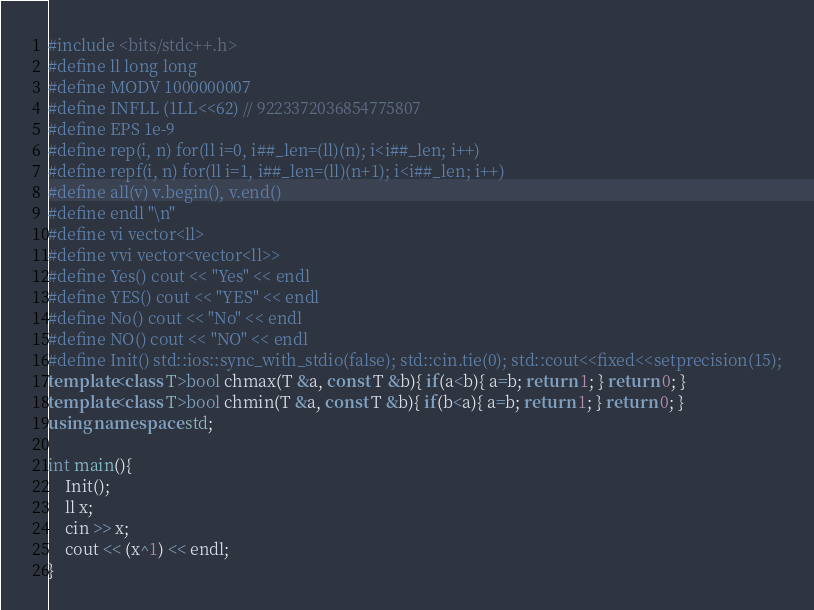Convert code to text. <code><loc_0><loc_0><loc_500><loc_500><_C++_>#include <bits/stdc++.h>
#define ll long long
#define MODV 1000000007
#define INFLL (1LL<<62) // 9223372036854775807
#define EPS 1e-9
#define rep(i, n) for(ll i=0, i##_len=(ll)(n); i<i##_len; i++)
#define repf(i, n) for(ll i=1, i##_len=(ll)(n+1); i<i##_len; i++)
#define all(v) v.begin(), v.end()
#define endl "\n"
#define vi vector<ll>
#define vvi vector<vector<ll>>
#define Yes() cout << "Yes" << endl
#define YES() cout << "YES" << endl
#define No() cout << "No" << endl
#define NO() cout << "NO" << endl
#define Init() std::ios::sync_with_stdio(false); std::cin.tie(0); std::cout<<fixed<<setprecision(15);
template<class T>bool chmax(T &a, const T &b){ if(a<b){ a=b; return 1; } return 0; }
template<class T>bool chmin(T &a, const T &b){ if(b<a){ a=b; return 1; } return 0; }
using namespace std;

int main(){
    Init();
    ll x;
    cin >> x;
    cout << (x^1) << endl;
}</code> 